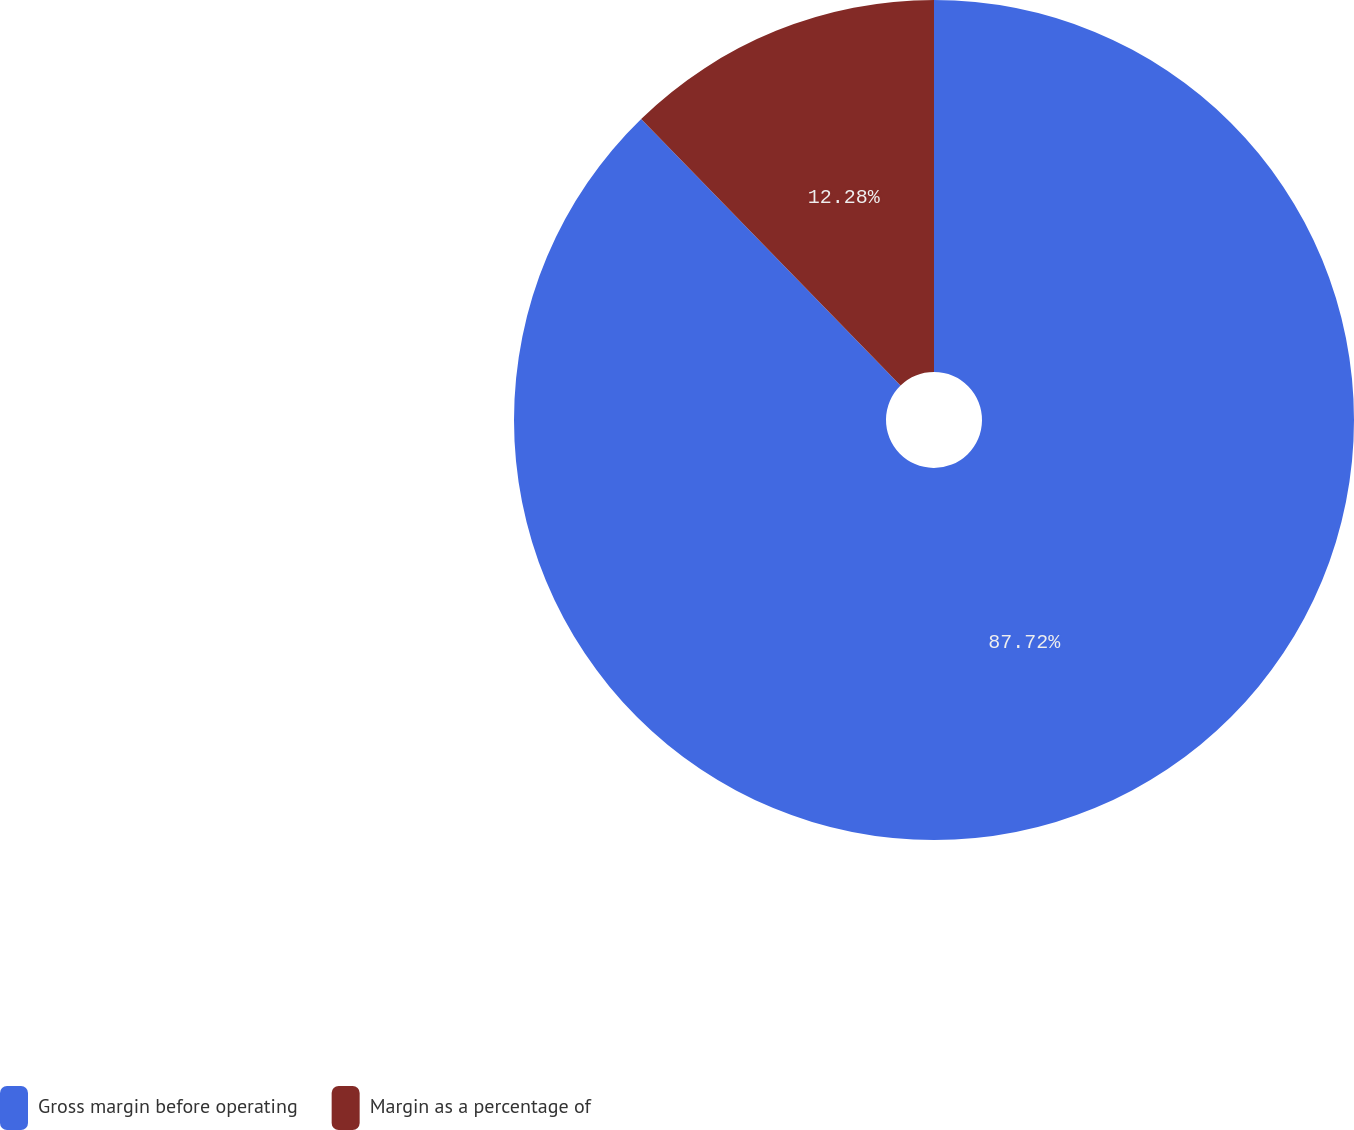Convert chart to OTSL. <chart><loc_0><loc_0><loc_500><loc_500><pie_chart><fcel>Gross margin before operating<fcel>Margin as a percentage of<nl><fcel>87.72%<fcel>12.28%<nl></chart> 